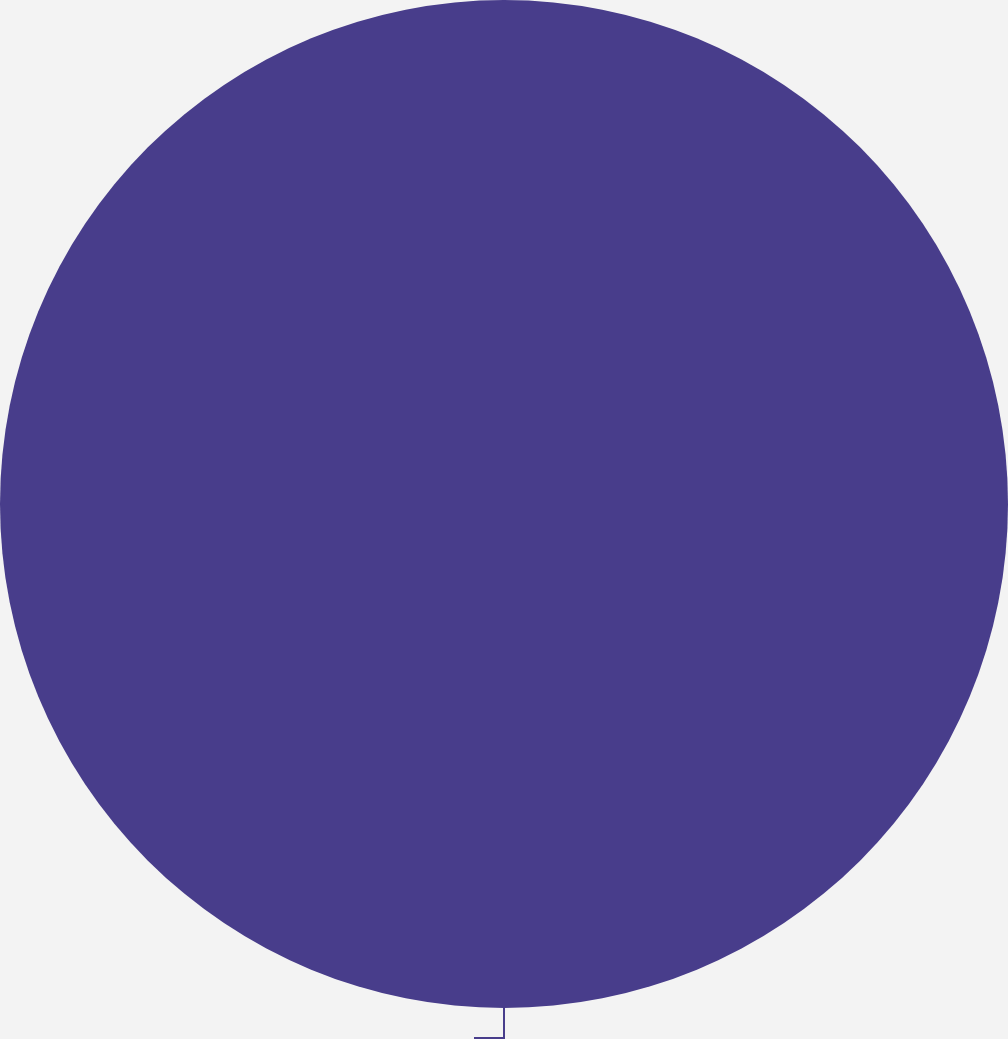<chart> <loc_0><loc_0><loc_500><loc_500><pie_chart><ecel><nl><fcel>100.0%<nl></chart> 